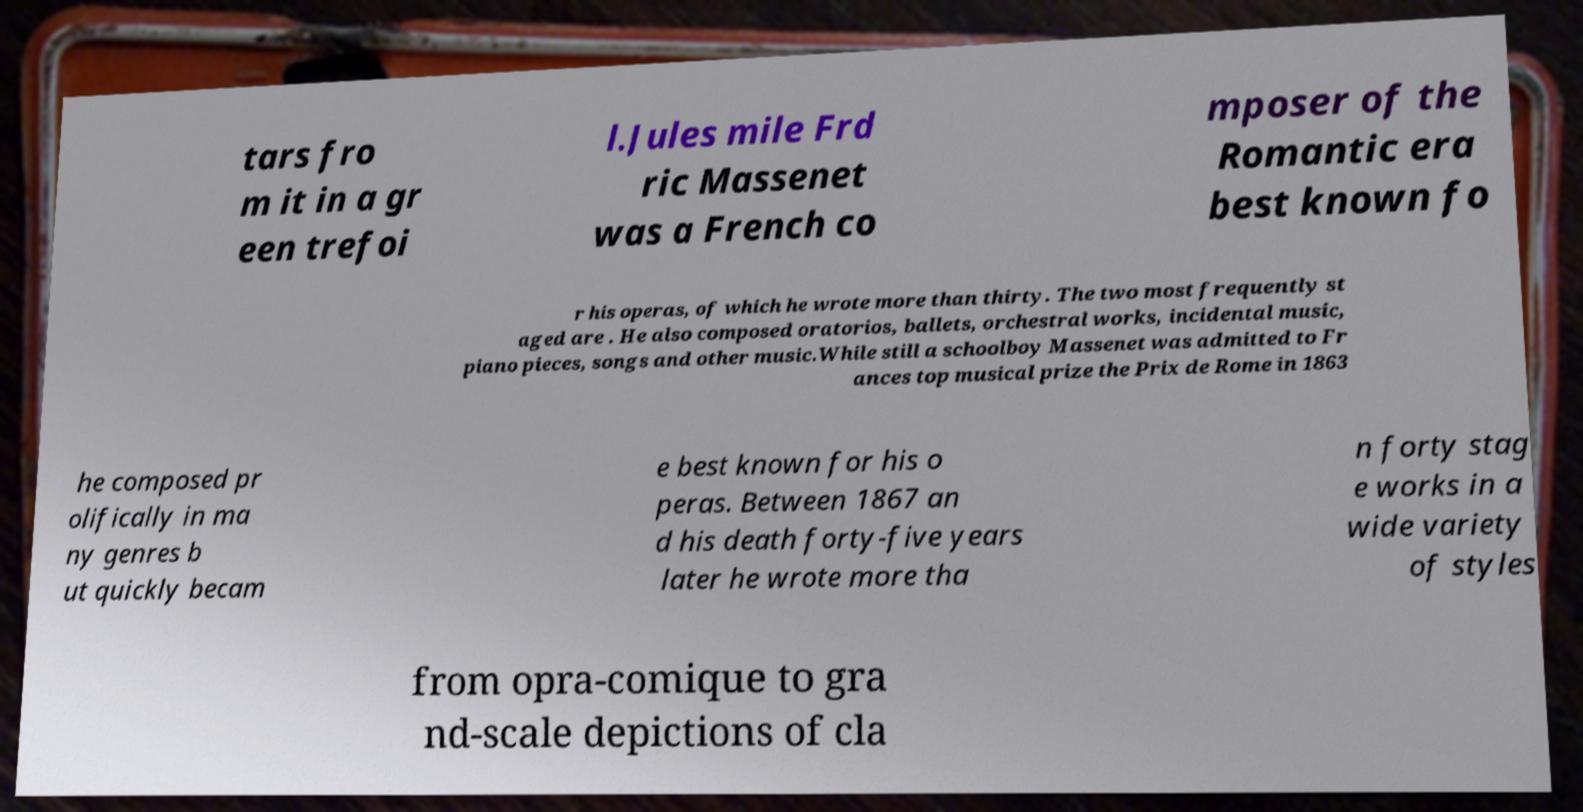Could you assist in decoding the text presented in this image and type it out clearly? tars fro m it in a gr een trefoi l.Jules mile Frd ric Massenet was a French co mposer of the Romantic era best known fo r his operas, of which he wrote more than thirty. The two most frequently st aged are . He also composed oratorios, ballets, orchestral works, incidental music, piano pieces, songs and other music.While still a schoolboy Massenet was admitted to Fr ances top musical prize the Prix de Rome in 1863 he composed pr olifically in ma ny genres b ut quickly becam e best known for his o peras. Between 1867 an d his death forty-five years later he wrote more tha n forty stag e works in a wide variety of styles from opra-comique to gra nd-scale depictions of cla 